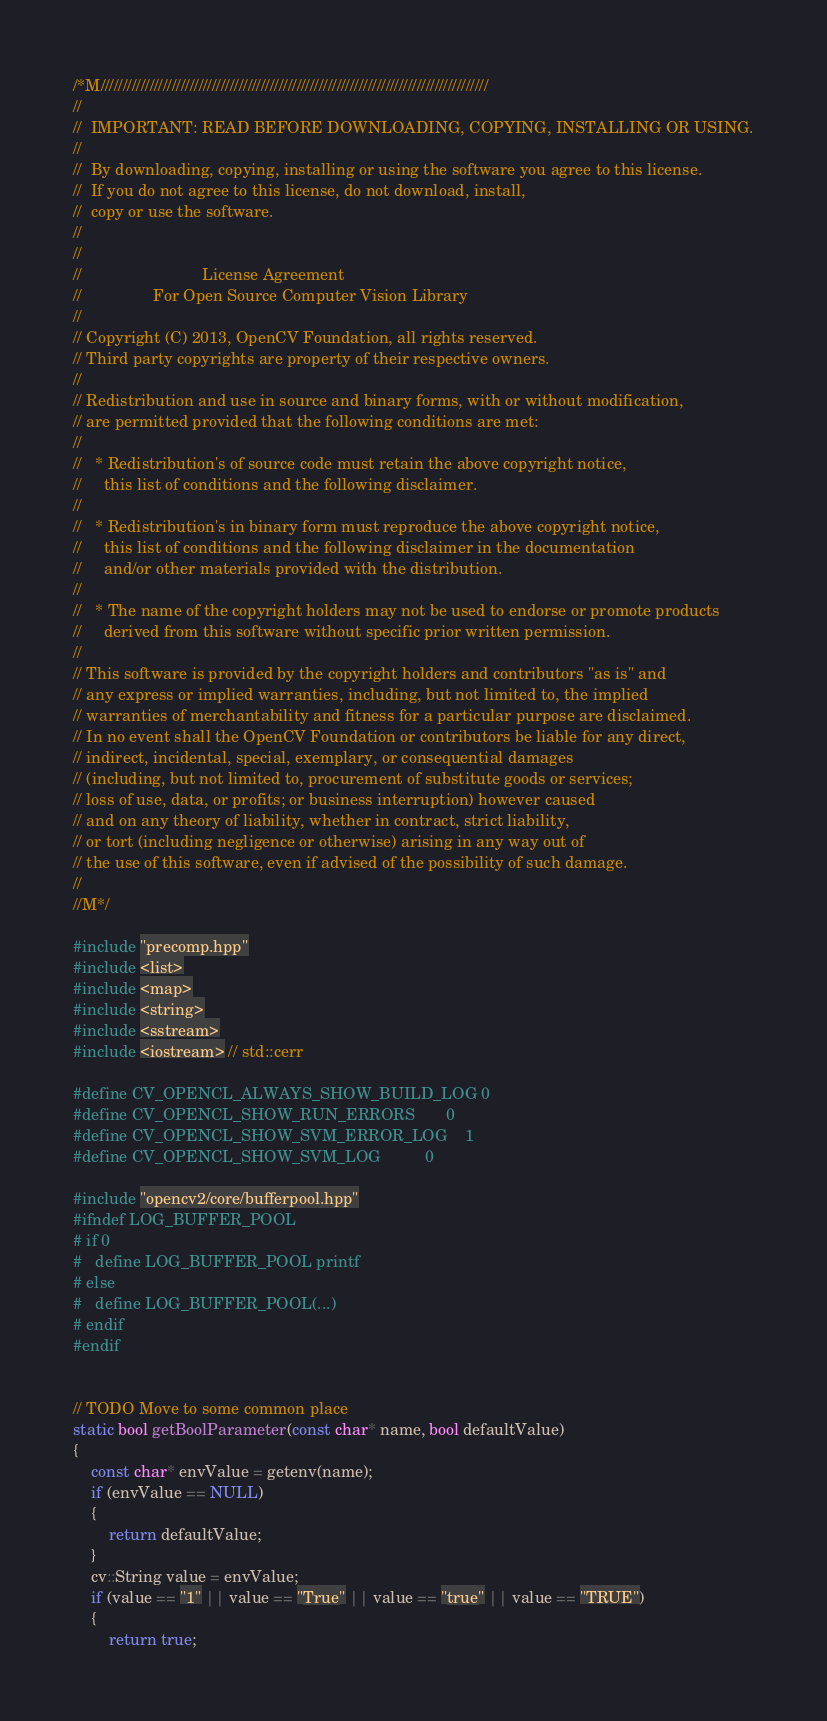Convert code to text. <code><loc_0><loc_0><loc_500><loc_500><_C++_>/*M///////////////////////////////////////////////////////////////////////////////////////
//
//  IMPORTANT: READ BEFORE DOWNLOADING, COPYING, INSTALLING OR USING.
//
//  By downloading, copying, installing or using the software you agree to this license.
//  If you do not agree to this license, do not download, install,
//  copy or use the software.
//
//
//                           License Agreement
//                For Open Source Computer Vision Library
//
// Copyright (C) 2013, OpenCV Foundation, all rights reserved.
// Third party copyrights are property of their respective owners.
//
// Redistribution and use in source and binary forms, with or without modification,
// are permitted provided that the following conditions are met:
//
//   * Redistribution's of source code must retain the above copyright notice,
//     this list of conditions and the following disclaimer.
//
//   * Redistribution's in binary form must reproduce the above copyright notice,
//     this list of conditions and the following disclaimer in the documentation
//     and/or other materials provided with the distribution.
//
//   * The name of the copyright holders may not be used to endorse or promote products
//     derived from this software without specific prior written permission.
//
// This software is provided by the copyright holders and contributors "as is" and
// any express or implied warranties, including, but not limited to, the implied
// warranties of merchantability and fitness for a particular purpose are disclaimed.
// In no event shall the OpenCV Foundation or contributors be liable for any direct,
// indirect, incidental, special, exemplary, or consequential damages
// (including, but not limited to, procurement of substitute goods or services;
// loss of use, data, or profits; or business interruption) however caused
// and on any theory of liability, whether in contract, strict liability,
// or tort (including negligence or otherwise) arising in any way out of
// the use of this software, even if advised of the possibility of such damage.
//
//M*/

#include "precomp.hpp"
#include <list>
#include <map>
#include <string>
#include <sstream>
#include <iostream> // std::cerr

#define CV_OPENCL_ALWAYS_SHOW_BUILD_LOG 0
#define CV_OPENCL_SHOW_RUN_ERRORS       0
#define CV_OPENCL_SHOW_SVM_ERROR_LOG    1
#define CV_OPENCL_SHOW_SVM_LOG          0

#include "opencv2/core/bufferpool.hpp"
#ifndef LOG_BUFFER_POOL
# if 0
#   define LOG_BUFFER_POOL printf
# else
#   define LOG_BUFFER_POOL(...)
# endif
#endif


// TODO Move to some common place
static bool getBoolParameter(const char* name, bool defaultValue)
{
    const char* envValue = getenv(name);
    if (envValue == NULL)
    {
        return defaultValue;
    }
    cv::String value = envValue;
    if (value == "1" || value == "True" || value == "true" || value == "TRUE")
    {
        return true;</code> 